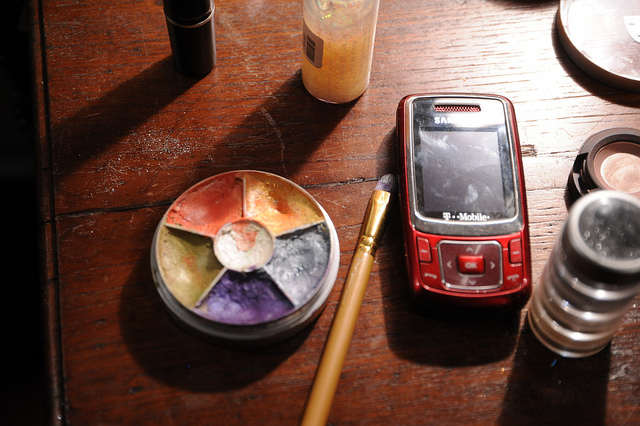Read and extract the text from this image. Mobile 